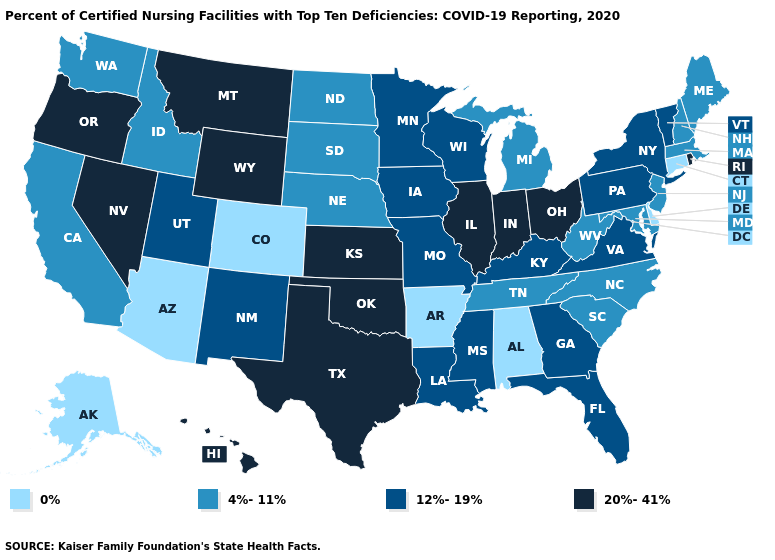Name the states that have a value in the range 4%-11%?
Concise answer only. California, Idaho, Maine, Maryland, Massachusetts, Michigan, Nebraska, New Hampshire, New Jersey, North Carolina, North Dakota, South Carolina, South Dakota, Tennessee, Washington, West Virginia. Which states hav the highest value in the MidWest?
Give a very brief answer. Illinois, Indiana, Kansas, Ohio. Name the states that have a value in the range 12%-19%?
Answer briefly. Florida, Georgia, Iowa, Kentucky, Louisiana, Minnesota, Mississippi, Missouri, New Mexico, New York, Pennsylvania, Utah, Vermont, Virginia, Wisconsin. What is the value of Wyoming?
Be succinct. 20%-41%. Does Washington have a higher value than Arkansas?
Write a very short answer. Yes. Name the states that have a value in the range 20%-41%?
Give a very brief answer. Hawaii, Illinois, Indiana, Kansas, Montana, Nevada, Ohio, Oklahoma, Oregon, Rhode Island, Texas, Wyoming. Name the states that have a value in the range 0%?
Concise answer only. Alabama, Alaska, Arizona, Arkansas, Colorado, Connecticut, Delaware. What is the value of Iowa?
Give a very brief answer. 12%-19%. Name the states that have a value in the range 12%-19%?
Answer briefly. Florida, Georgia, Iowa, Kentucky, Louisiana, Minnesota, Mississippi, Missouri, New Mexico, New York, Pennsylvania, Utah, Vermont, Virginia, Wisconsin. Does the map have missing data?
Be succinct. No. What is the highest value in the USA?
Give a very brief answer. 20%-41%. What is the value of Alabama?
Be succinct. 0%. What is the highest value in the Northeast ?
Write a very short answer. 20%-41%. Name the states that have a value in the range 12%-19%?
Give a very brief answer. Florida, Georgia, Iowa, Kentucky, Louisiana, Minnesota, Mississippi, Missouri, New Mexico, New York, Pennsylvania, Utah, Vermont, Virginia, Wisconsin. Name the states that have a value in the range 12%-19%?
Quick response, please. Florida, Georgia, Iowa, Kentucky, Louisiana, Minnesota, Mississippi, Missouri, New Mexico, New York, Pennsylvania, Utah, Vermont, Virginia, Wisconsin. 